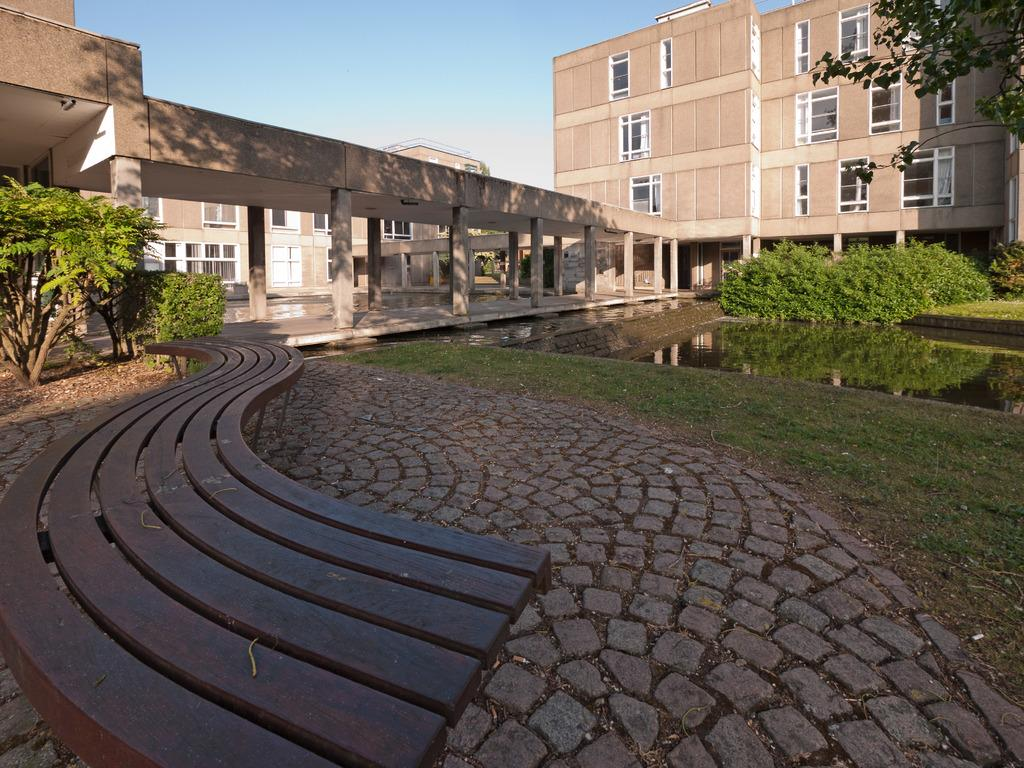What type of seating is present in the image? There is a bench in the image. What is the texture of the ground in the image? The ground has cobblestones. What type of vegetation can be seen in the image? There are plants and trees in the image. What natural element is visible in the image? There is water visible in the image. What type of structure is visible in the background of the image? There is a building in the background of the image. What is the condition of the sky in the image? The sky is clear and visible in the background of the image. Reasoning: Let'g: Let's think step by step in order to produce the conversation. We start by identifying the main subjects and objects in the image based on the provided facts. We then formulate questions that focus on the location and characteristics of these subjects and objects, ensuring that each question can be answered definitively with the information given. We avoid yes/no questions and ensure that the language is simple and clear. Absurd Question/Answer: How many geese are walking on the cobblestones in the image? There are no geese present in the image. Is there a spy observing the building in the background of the image? There is no indication of a spy or any person observing the building in the image. How many geese are walking on the cobblestones in the image? There are no geese present in the image. Is there a spy observing the building in the background of the image? There is no indication of a spy or any person observing the building in the image. 